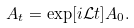<formula> <loc_0><loc_0><loc_500><loc_500>A _ { t } = \exp [ i \mathcal { L } t ] A _ { 0 } .</formula> 